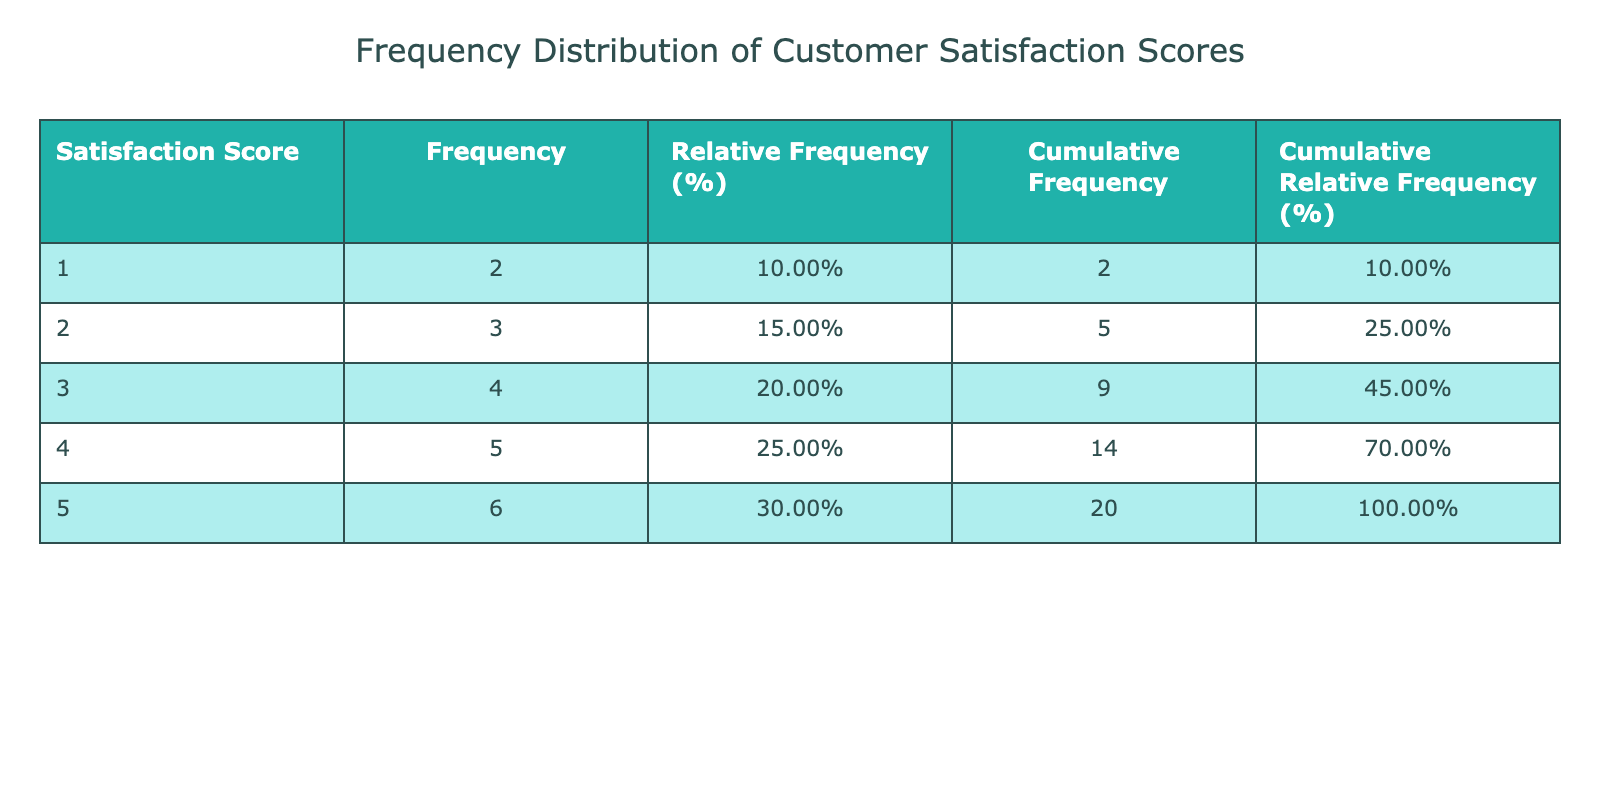What is the highest satisfaction score recorded? The table lists satisfaction scores ranging from 1 to 5. The score with the highest value is 5.
Answer: 5 What is the frequency of customers who rated the product with a score of 2? Looking at the frequency column in the table, the score of 2 has a frequency count of 3.
Answer: 3 How many customers rated the product with a score of 4 or higher? To get this, we sum the frequencies for scores of 4 and 5: frequency of 4 is 6 and frequency of 5 is 5. Therefore, total = 6 + 5 = 11.
Answer: 11 What percentage of customers rated the product with a satisfaction score of 1? The frequency of score 1 is 2, and there are 20 customers total. The relative frequency is calculated as (2/20)*100 = 10%.
Answer: 10% Did more customers rate the product with a satisfaction score of 3 than those who rated it with a score of 1? The score of 3 has a frequency of 5, while the score of 1 has a frequency of 2. Since 5 is greater than 2, the answer is yes.
Answer: Yes What is the cumulative frequency for a satisfaction score of 3? The cumulative frequency for a score of 3 includes the frequencies for scores of 1, 2, and 3. The frequencies are: 2 (score 1) + 3 (score 2) + 5 (score 3) = 10.
Answer: 10 What is the average satisfaction score based on the frequencies? To find the average, we first compute the total satisfaction score value: (5*5 + 4*6 + 3*5 + 2*3 + 1*2) = 45, then divide by the total number of customers (20): 45/20 = 2.25.
Answer: 2.25 What is the difference in relative frequency between satisfaction scores of 5 and 1? The relative frequency for score 5 is 25% (5 out of 20 customers) and for score 1 is 10% (2 out of 20 customers). The difference is 25% - 10% = 15%.
Answer: 15% How many customers reported satisfaction scores of exactly 3 or less? To find this, we sum the frequencies for scores of 1, 2, and 3: 2 (score 1) + 3 (score 2) + 5 (score 3) = 10 customers in total.
Answer: 10 